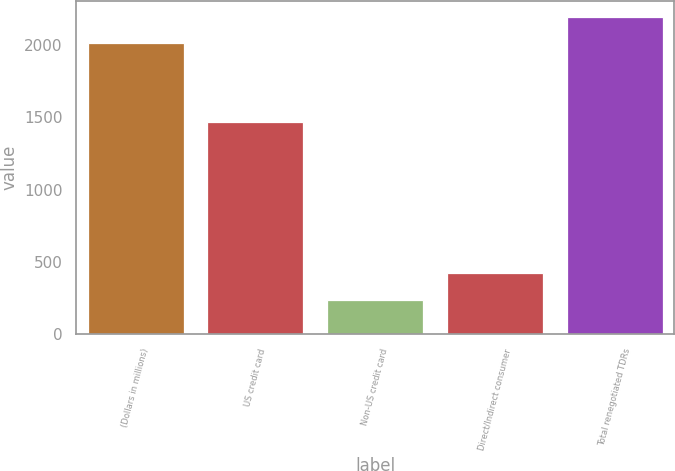<chart> <loc_0><loc_0><loc_500><loc_500><bar_chart><fcel>(Dollars in millions)<fcel>US credit card<fcel>Non-US credit card<fcel>Direct/Indirect consumer<fcel>Total renegotiated TDRs<nl><fcel>2013<fcel>1465<fcel>240<fcel>423.9<fcel>2196.9<nl></chart> 